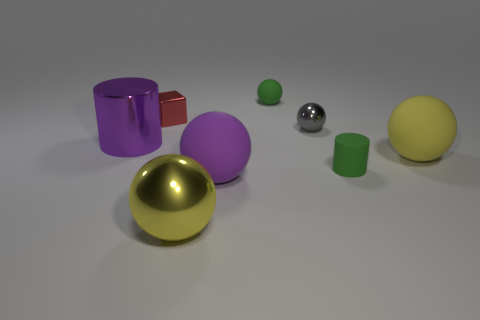Add 1 gray rubber spheres. How many objects exist? 9 Subtract all metallic spheres. How many spheres are left? 3 Subtract all gray spheres. How many spheres are left? 4 Subtract all purple spheres. Subtract all purple cylinders. How many spheres are left? 4 Subtract all blocks. How many objects are left? 7 Add 8 green metallic things. How many green metallic things exist? 8 Subtract 1 purple cylinders. How many objects are left? 7 Subtract all tiny matte balls. Subtract all gray shiny things. How many objects are left? 6 Add 2 tiny green things. How many tiny green things are left? 4 